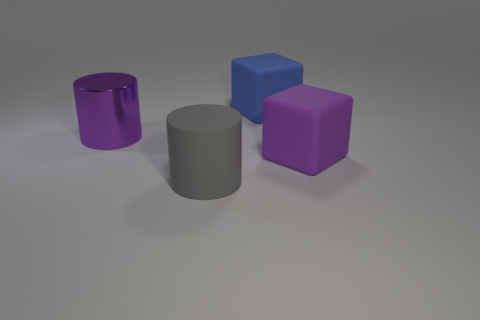Add 3 large yellow rubber things. How many objects exist? 7 Subtract all gray cylinders. How many blue cubes are left? 1 Subtract all large gray rubber objects. Subtract all big purple cylinders. How many objects are left? 2 Add 4 blue objects. How many blue objects are left? 5 Add 1 big purple metal cylinders. How many big purple metal cylinders exist? 2 Subtract 0 yellow cubes. How many objects are left? 4 Subtract 1 cylinders. How many cylinders are left? 1 Subtract all blue blocks. Subtract all blue spheres. How many blocks are left? 1 